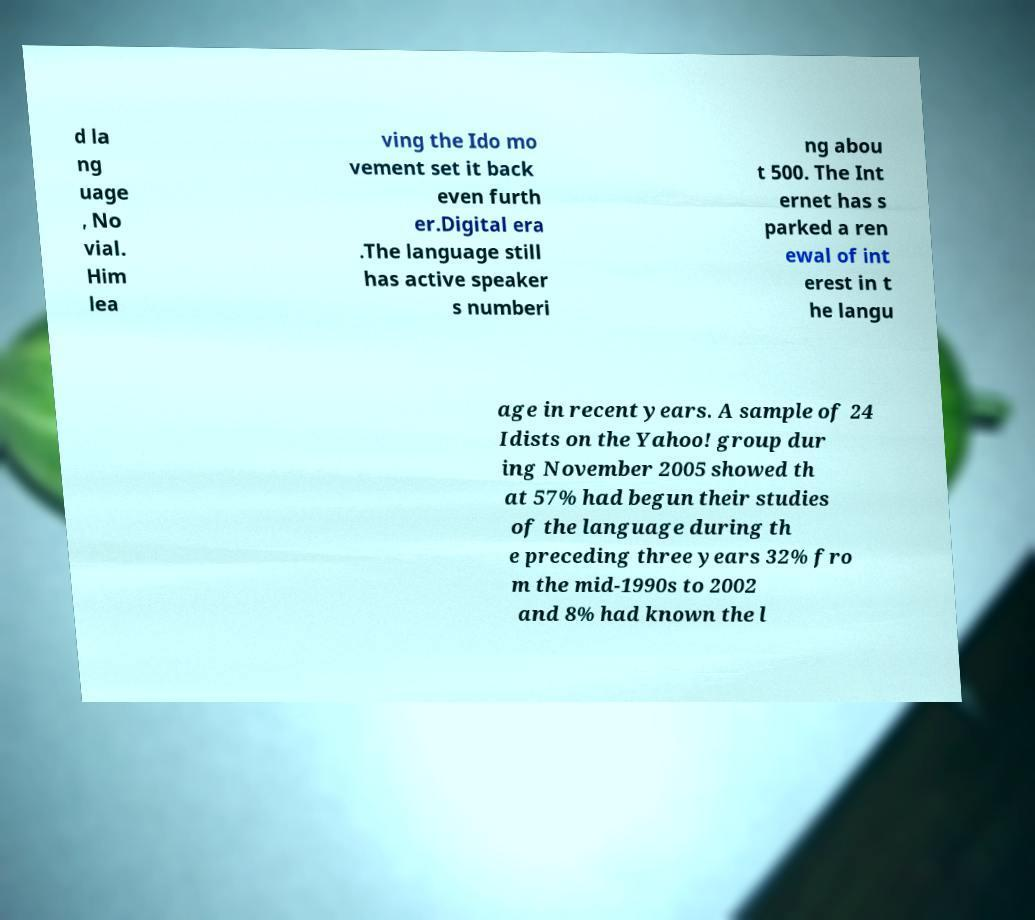Please read and relay the text visible in this image. What does it say? d la ng uage , No vial. Him lea ving the Ido mo vement set it back even furth er.Digital era .The language still has active speaker s numberi ng abou t 500. The Int ernet has s parked a ren ewal of int erest in t he langu age in recent years. A sample of 24 Idists on the Yahoo! group dur ing November 2005 showed th at 57% had begun their studies of the language during th e preceding three years 32% fro m the mid-1990s to 2002 and 8% had known the l 